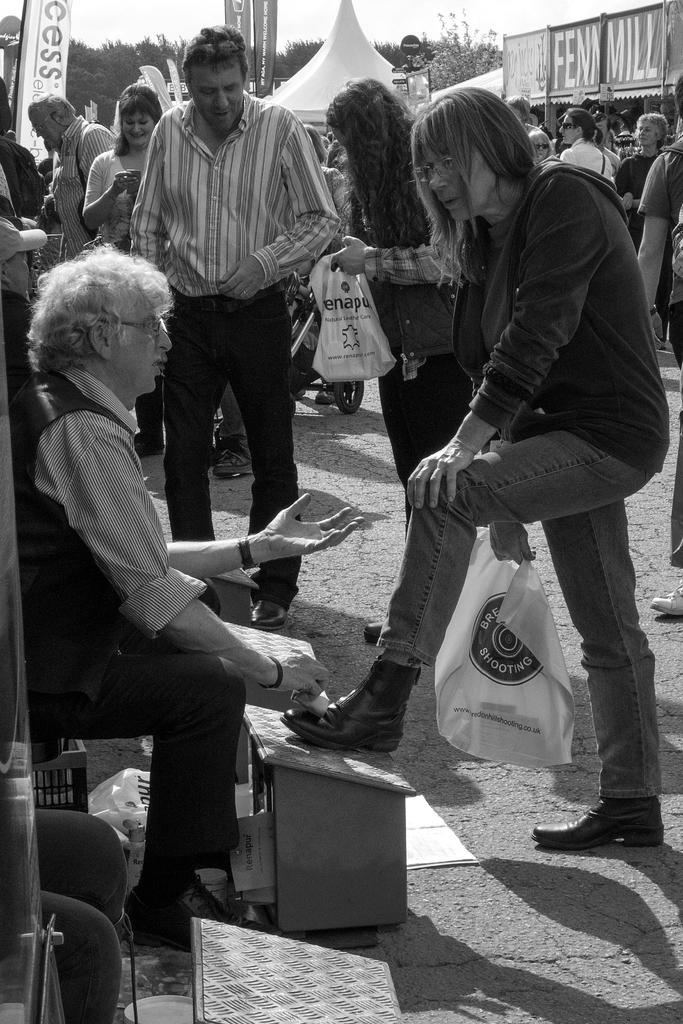Describe this image in one or two sentences. In the bottom left of the image there are legs of a person. In front of the legs there is a stand. There is a man sitting and polishing the shoes. In front of him there is a person standing and holding a cover in the hands. Behind them there are few people standing. In the background there are posters, trees and store with name board. 